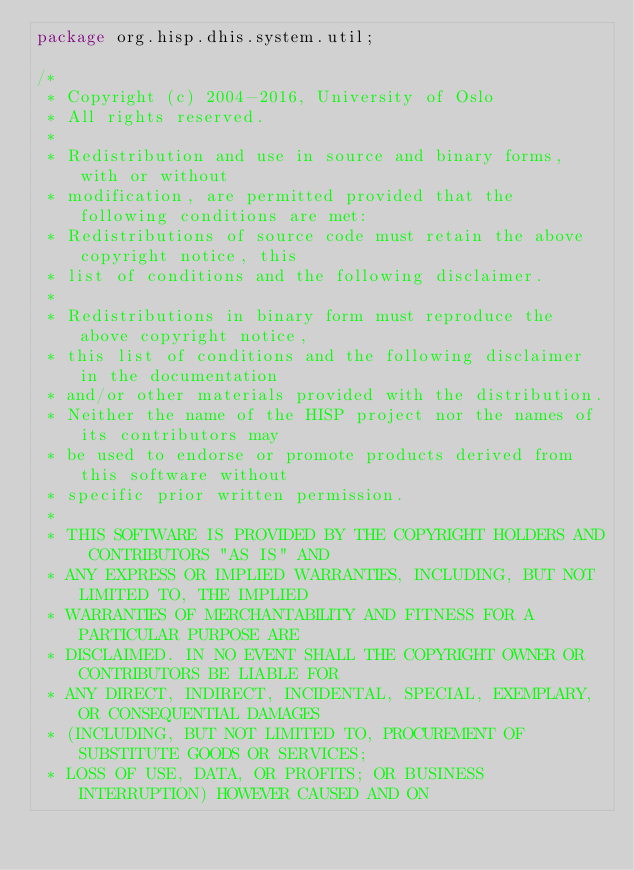<code> <loc_0><loc_0><loc_500><loc_500><_Java_>package org.hisp.dhis.system.util;

/*
 * Copyright (c) 2004-2016, University of Oslo
 * All rights reserved.
 *
 * Redistribution and use in source and binary forms, with or without
 * modification, are permitted provided that the following conditions are met:
 * Redistributions of source code must retain the above copyright notice, this
 * list of conditions and the following disclaimer.
 *
 * Redistributions in binary form must reproduce the above copyright notice,
 * this list of conditions and the following disclaimer in the documentation
 * and/or other materials provided with the distribution.
 * Neither the name of the HISP project nor the names of its contributors may
 * be used to endorse or promote products derived from this software without
 * specific prior written permission.
 *
 * THIS SOFTWARE IS PROVIDED BY THE COPYRIGHT HOLDERS AND CONTRIBUTORS "AS IS" AND
 * ANY EXPRESS OR IMPLIED WARRANTIES, INCLUDING, BUT NOT LIMITED TO, THE IMPLIED
 * WARRANTIES OF MERCHANTABILITY AND FITNESS FOR A PARTICULAR PURPOSE ARE
 * DISCLAIMED. IN NO EVENT SHALL THE COPYRIGHT OWNER OR CONTRIBUTORS BE LIABLE FOR
 * ANY DIRECT, INDIRECT, INCIDENTAL, SPECIAL, EXEMPLARY, OR CONSEQUENTIAL DAMAGES
 * (INCLUDING, BUT NOT LIMITED TO, PROCUREMENT OF SUBSTITUTE GOODS OR SERVICES;
 * LOSS OF USE, DATA, OR PROFITS; OR BUSINESS INTERRUPTION) HOWEVER CAUSED AND ON</code> 